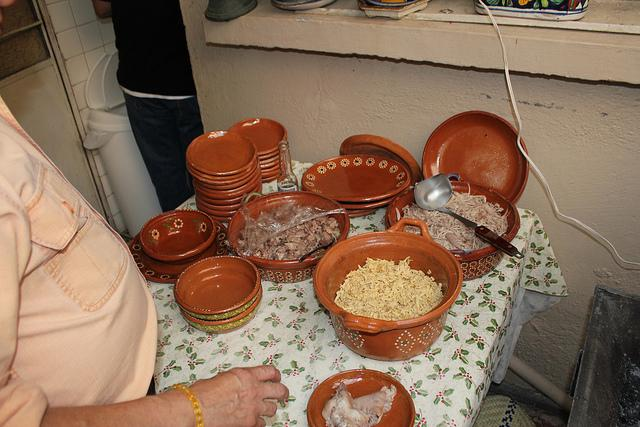Where is this food located? Please explain your reasoning. home kitchen. The food is at home. 